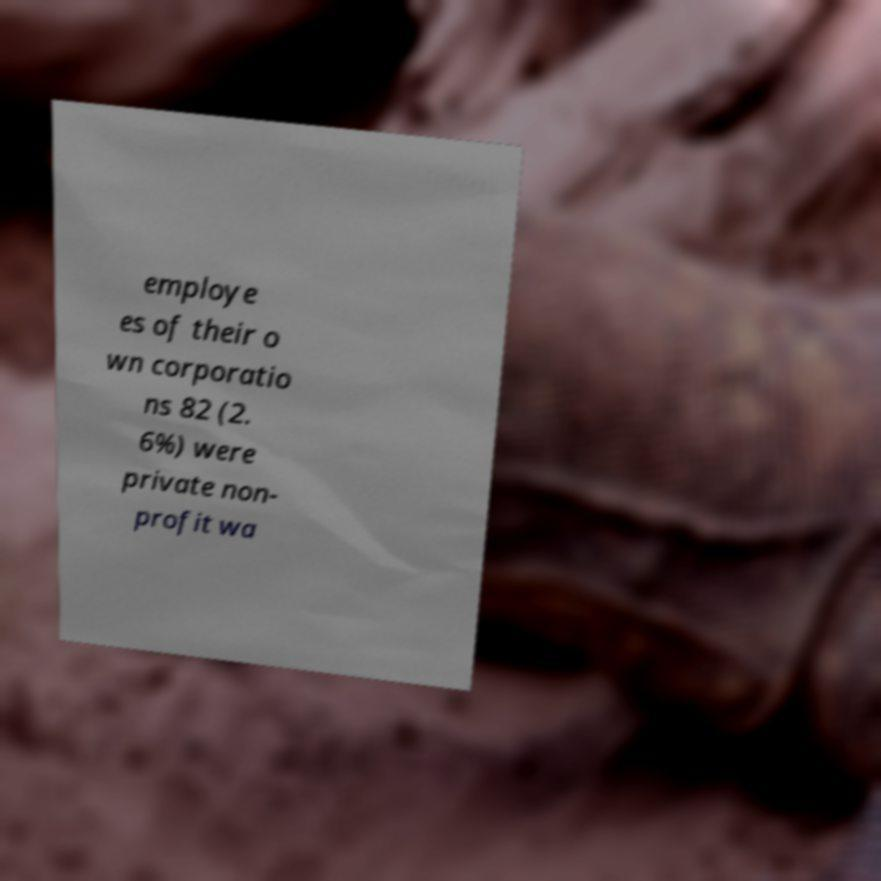There's text embedded in this image that I need extracted. Can you transcribe it verbatim? employe es of their o wn corporatio ns 82 (2. 6%) were private non- profit wa 